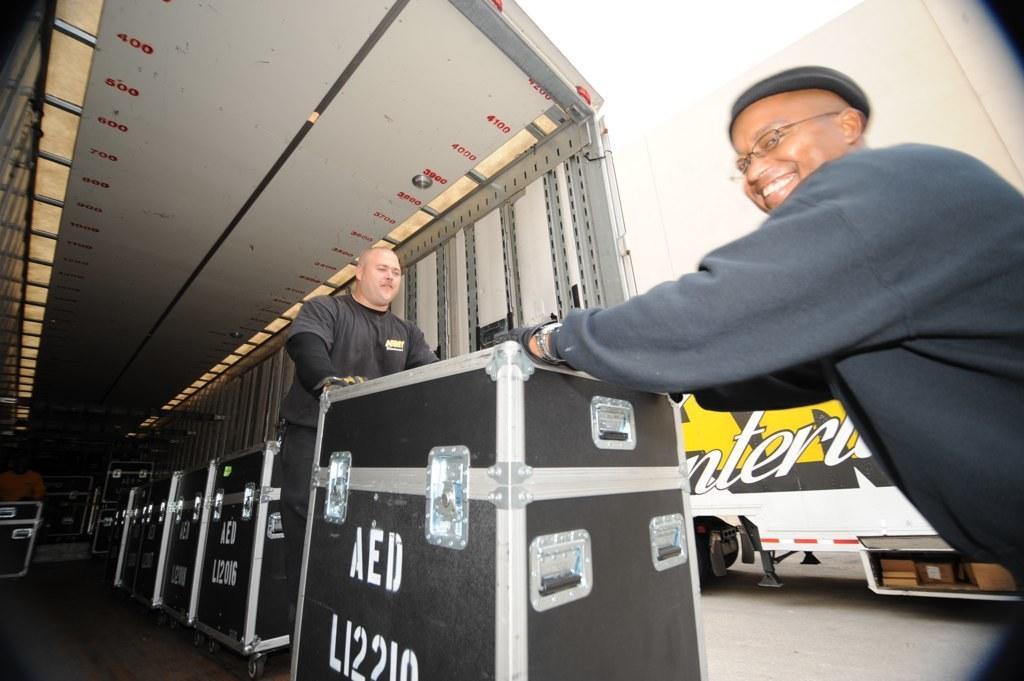How would you summarize this image in a sentence or two? In this image I can see two people. I can see the boxes. 